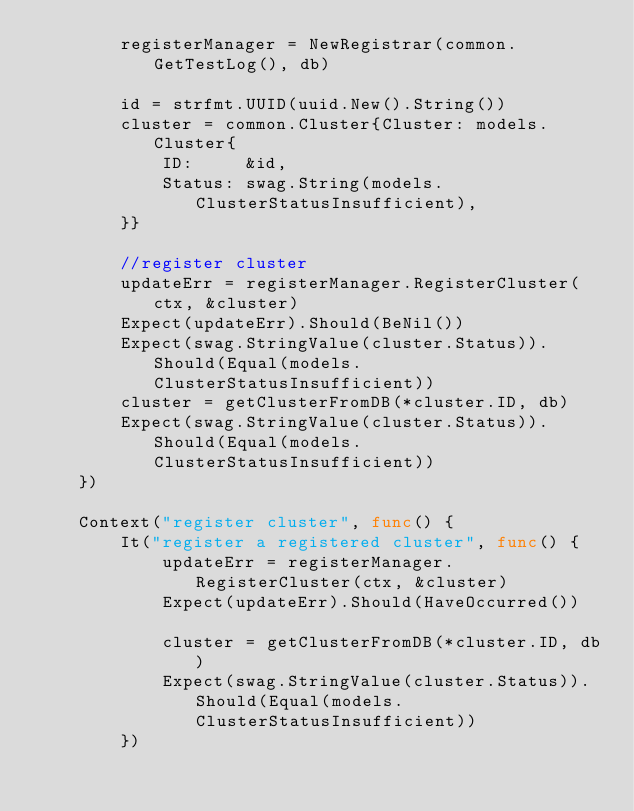<code> <loc_0><loc_0><loc_500><loc_500><_Go_>		registerManager = NewRegistrar(common.GetTestLog(), db)

		id = strfmt.UUID(uuid.New().String())
		cluster = common.Cluster{Cluster: models.Cluster{
			ID:     &id,
			Status: swag.String(models.ClusterStatusInsufficient),
		}}

		//register cluster
		updateErr = registerManager.RegisterCluster(ctx, &cluster)
		Expect(updateErr).Should(BeNil())
		Expect(swag.StringValue(cluster.Status)).Should(Equal(models.ClusterStatusInsufficient))
		cluster = getClusterFromDB(*cluster.ID, db)
		Expect(swag.StringValue(cluster.Status)).Should(Equal(models.ClusterStatusInsufficient))
	})

	Context("register cluster", func() {
		It("register a registered cluster", func() {
			updateErr = registerManager.RegisterCluster(ctx, &cluster)
			Expect(updateErr).Should(HaveOccurred())

			cluster = getClusterFromDB(*cluster.ID, db)
			Expect(swag.StringValue(cluster.Status)).Should(Equal(models.ClusterStatusInsufficient))
		})
</code> 